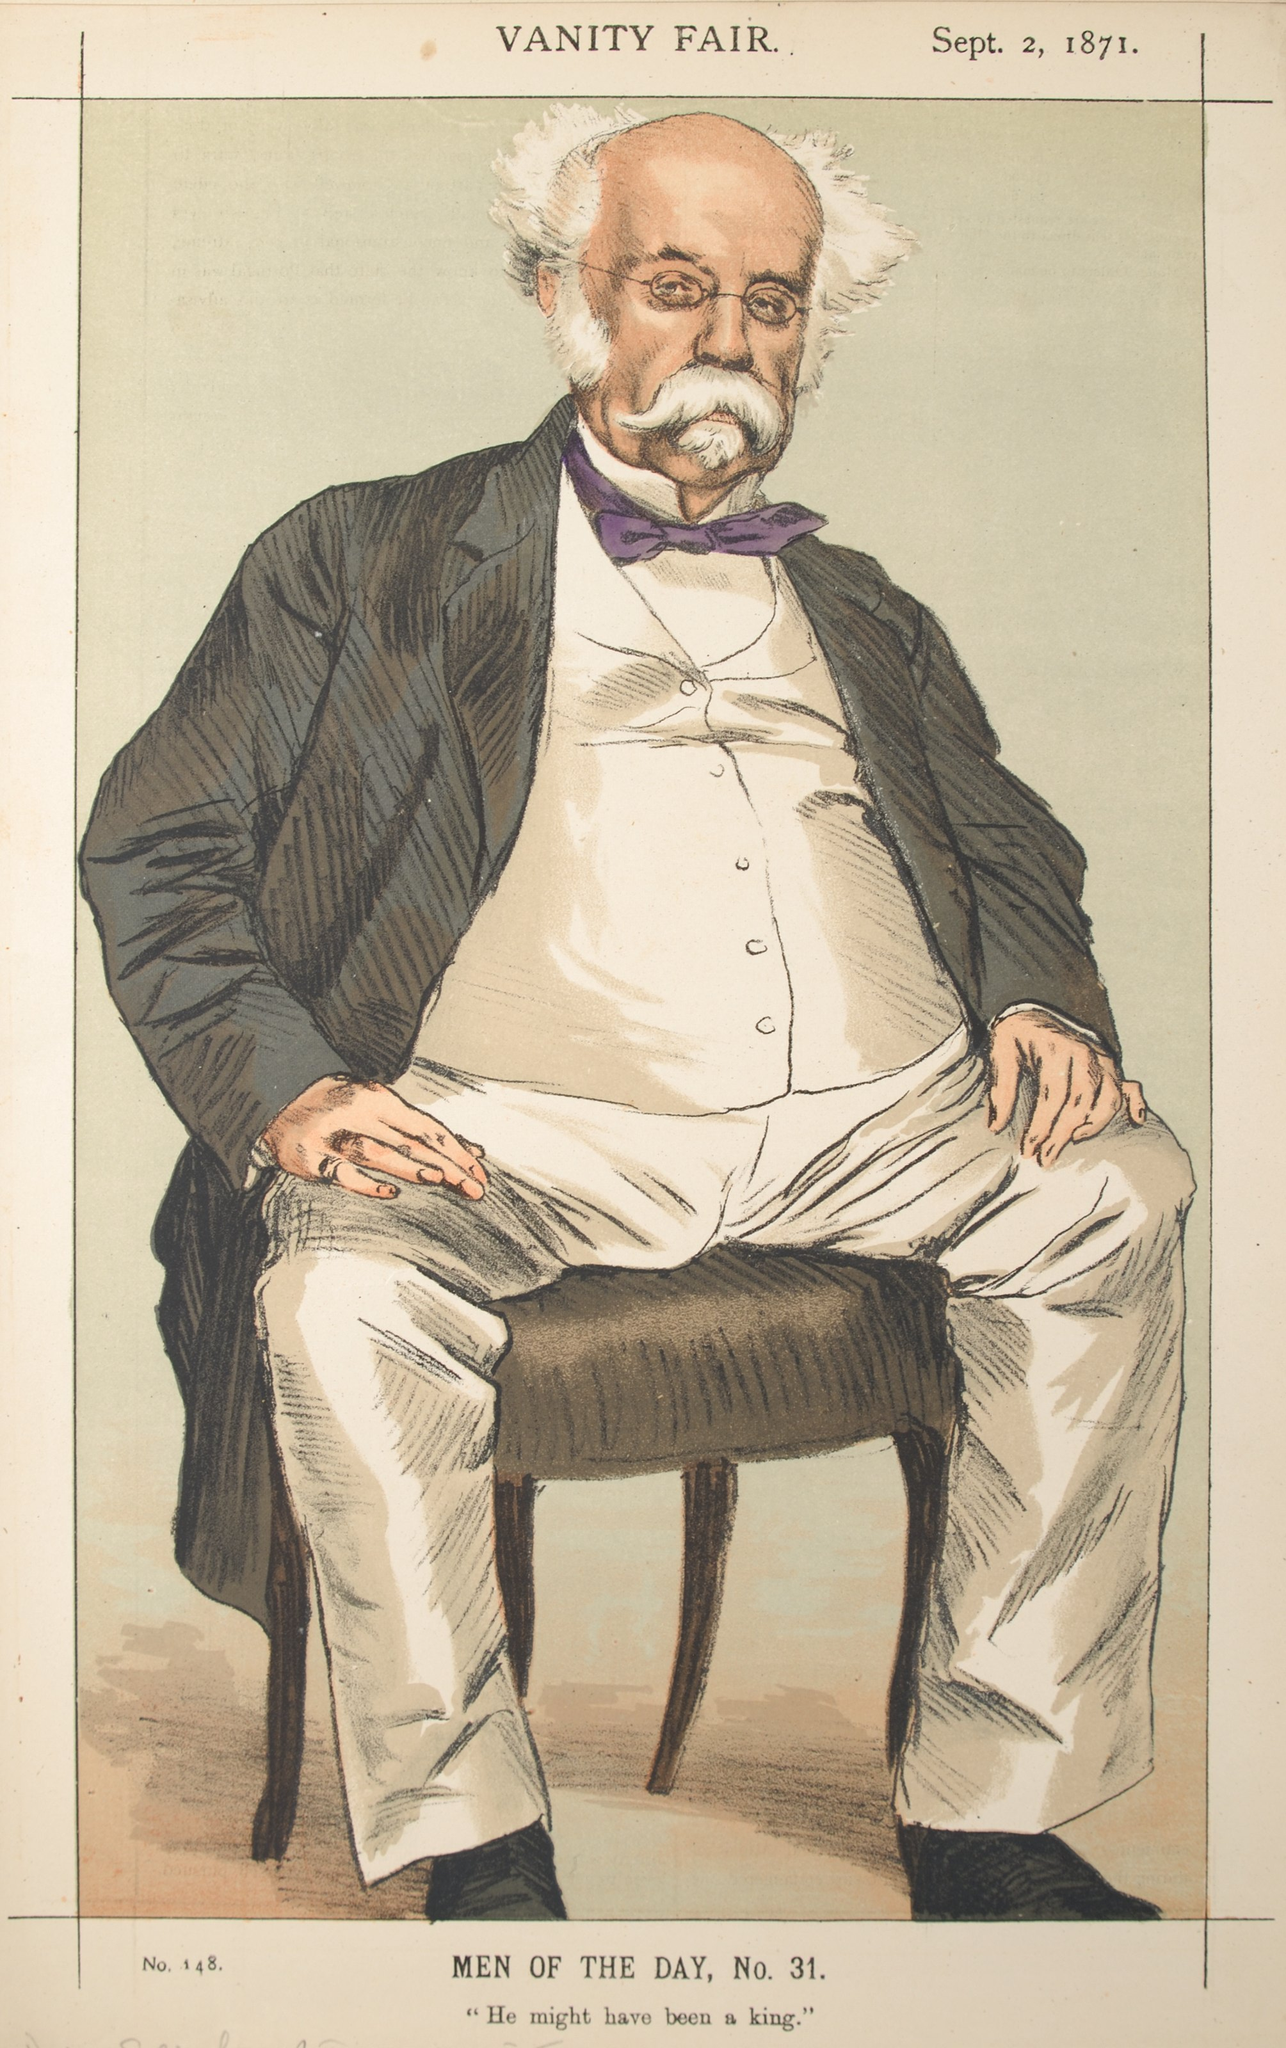Describe the following image. The image is an art piece from the September 2, 1871 issue of Vanity Fair. It features a satirical caricature of a man seated on a chair. He is dressed in a black suit, white shirt, and a distinct purple bowtie. His physical features include a noticeable balding head and a white beard. The illustration style, common of the satirical genre of that time period, employs bold lines and exaggerated attributes to humorously critique his appearance and demeanor. The text on the image reads ‘VANITY FAIR. Sept. 2, 1871. No. 148’, placing it in the context of a popular publication known for its satirical content. 